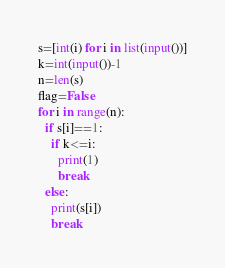Convert code to text. <code><loc_0><loc_0><loc_500><loc_500><_Python_>s=[int(i) for i in list(input())]
k=int(input())-1
n=len(s)
flag=False
for i in range(n):
  if s[i]==1:
    if k<=i:
      print(1)
      break
  else:
    print(s[i])
    break</code> 